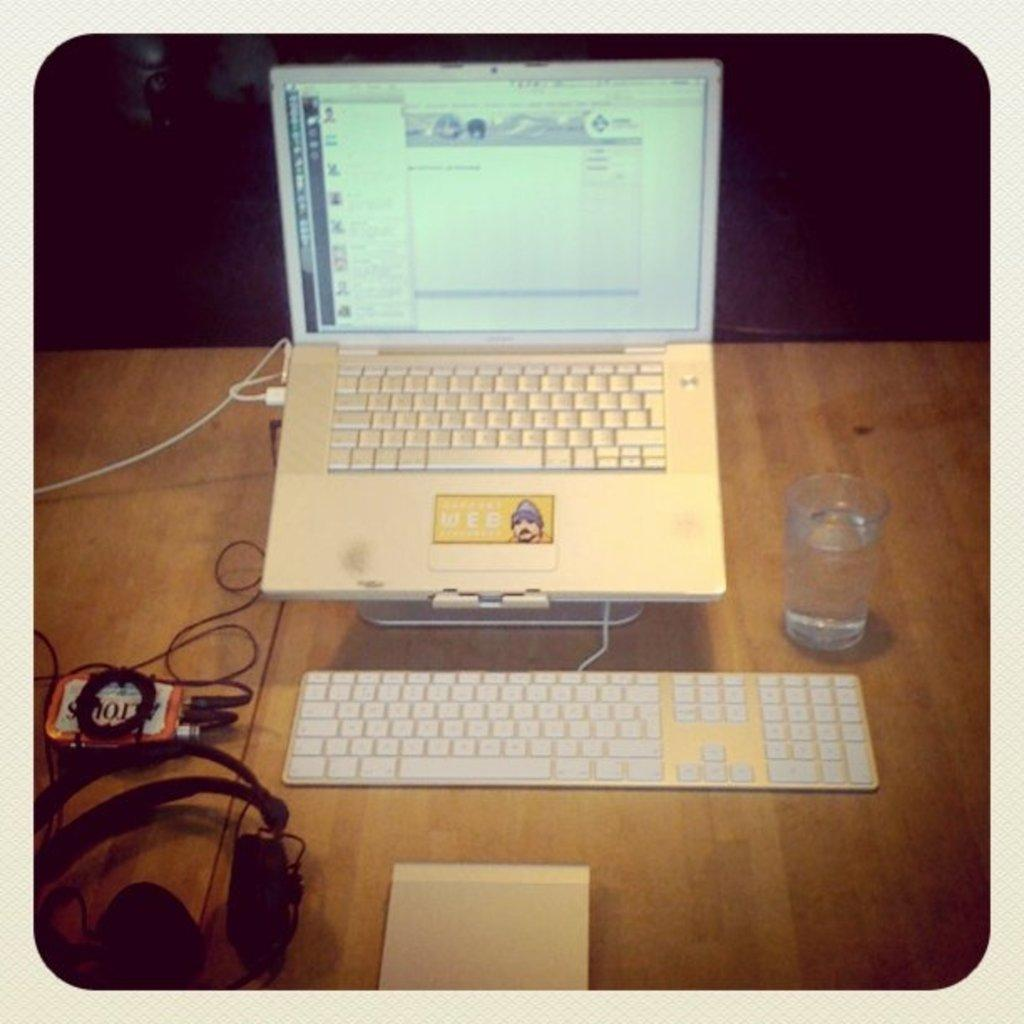Provide a one-sentence caption for the provided image. An open turned on laptop with periferals plugged into an Altoids can. 